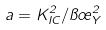Convert formula to latex. <formula><loc_0><loc_0><loc_500><loc_500>a = K _ { I C } ^ { 2 } / \pi \sigma _ { Y } ^ { 2 }</formula> 